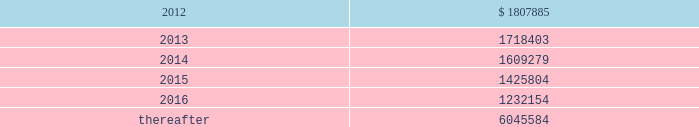Vornado realty trust notes to consolidated financial statements ( continued ) 17 .
Leases as lessor : we lease space to tenants under operating leases .
Most of the leases provide for the payment of fixed base rentals payable monthly in advance .
Office building leases generally require the tenants to reimburse us for operating costs and real estate taxes above their base year costs .
Shopping center leases provide for pass-through to tenants the tenant 2019s share of real estate taxes , insurance and maintenance .
Shopping center leases also provide for the payment by the lessee of additional rent based on a percentage of the tenants 2019 sales .
As of december 31 , 2011 , future base rental revenue under non-cancelable operating leases , excluding rents for leases with an original term of less than one year and rents resulting from the exercise of renewal options , is as follows : ( amounts in thousands ) year ending december 31: .
These amounts do not include percentage rentals based on tenants 2019 sales .
These percentage rents approximated $ 8482000 , $ 7912000 and $ 8394000 , for the years ended december 31 , 2011 , 2010 and 2009 , respectively .
None of our tenants accounted for more than 10% ( 10 % ) of total revenues in any of the years ended december 31 , 2011 , 2010 and 2009 .
Former bradlees locations pursuant to a master agreement and guaranty , dated may 1 , 1992 , we are due $ 5000000 per annum of additional rent from stop & shop which was allocated to certain bradlees former locations .
On december 31 , 2002 , prior to the expiration of the leases to which the additional rent was allocated , we reallocated this rent to other former bradlees leases also guaranteed by stop & shop .
Stop & shop is contesting our right to reallocate and claims that we are no longer entitled to the additional rent .
On november 7 , 2011 , the court determined that we have a continuing right to allocate the annual rent to unexpired leases covered by the master agreement and guaranty and directed entry of a judgment in our favor ordering stop & shop to pay us the unpaid annual rent ( see note 20 2013 commitments and contingencies 2013 litigation ) .
As of december 31 , 2011 , we have a $ 41983000 receivable from stop and shop. .
Did future base rental revenue under non-cancelable operating leases , excluding rents for leases with an original term of less than one year and rents resulting from the exercise of renewal options , decrease from 2012 to 2013? 
Computations: (1807885 > 1718403)
Answer: yes. 